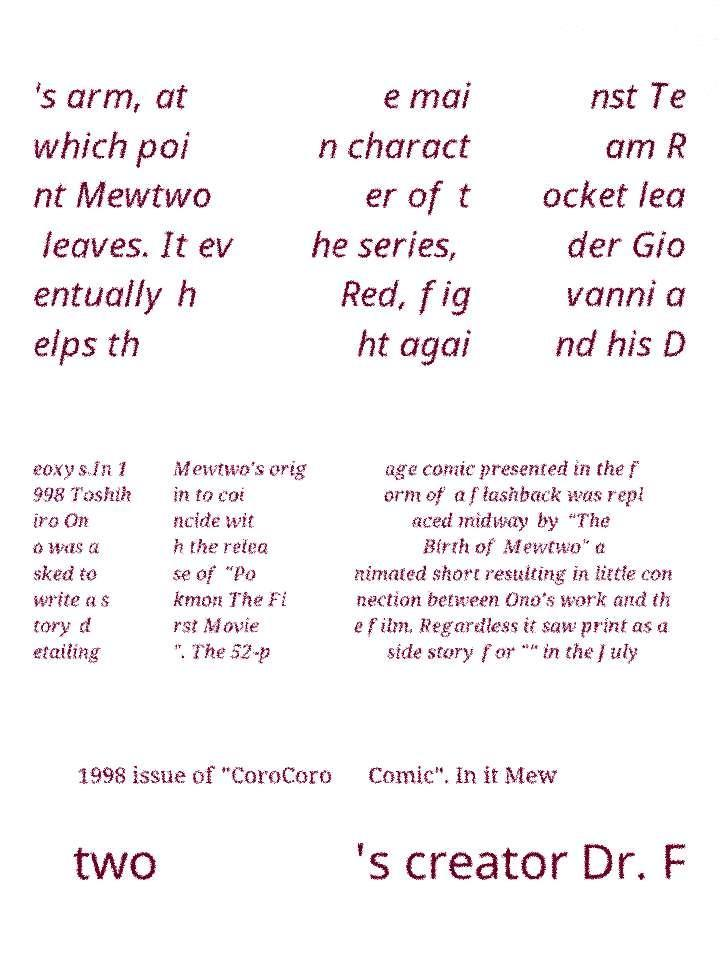What messages or text are displayed in this image? I need them in a readable, typed format. 's arm, at which poi nt Mewtwo leaves. It ev entually h elps th e mai n charact er of t he series, Red, fig ht agai nst Te am R ocket lea der Gio vanni a nd his D eoxys.In 1 998 Toshih iro On o was a sked to write a s tory d etailing Mewtwo's orig in to coi ncide wit h the relea se of "Po kmon The Fi rst Movie ". The 52-p age comic presented in the f orm of a flashback was repl aced midway by "The Birth of Mewtwo" a nimated short resulting in little con nection between Ono's work and th e film. Regardless it saw print as a side story for "" in the July 1998 issue of "CoroCoro Comic". In it Mew two 's creator Dr. F 